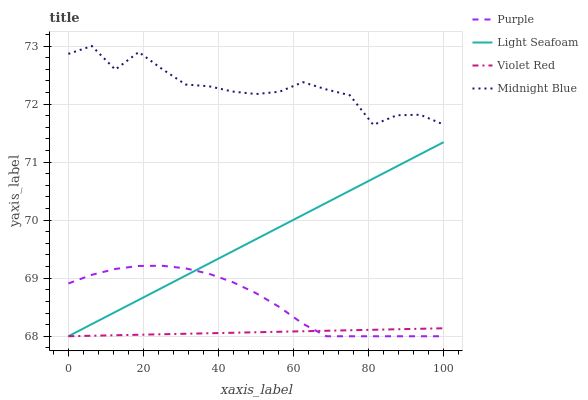Does Violet Red have the minimum area under the curve?
Answer yes or no. Yes. Does Midnight Blue have the maximum area under the curve?
Answer yes or no. Yes. Does Light Seafoam have the minimum area under the curve?
Answer yes or no. No. Does Light Seafoam have the maximum area under the curve?
Answer yes or no. No. Is Violet Red the smoothest?
Answer yes or no. Yes. Is Midnight Blue the roughest?
Answer yes or no. Yes. Is Light Seafoam the smoothest?
Answer yes or no. No. Is Light Seafoam the roughest?
Answer yes or no. No. Does Purple have the lowest value?
Answer yes or no. Yes. Does Midnight Blue have the lowest value?
Answer yes or no. No. Does Midnight Blue have the highest value?
Answer yes or no. Yes. Does Light Seafoam have the highest value?
Answer yes or no. No. Is Violet Red less than Midnight Blue?
Answer yes or no. Yes. Is Midnight Blue greater than Violet Red?
Answer yes or no. Yes. Does Violet Red intersect Light Seafoam?
Answer yes or no. Yes. Is Violet Red less than Light Seafoam?
Answer yes or no. No. Is Violet Red greater than Light Seafoam?
Answer yes or no. No. Does Violet Red intersect Midnight Blue?
Answer yes or no. No. 